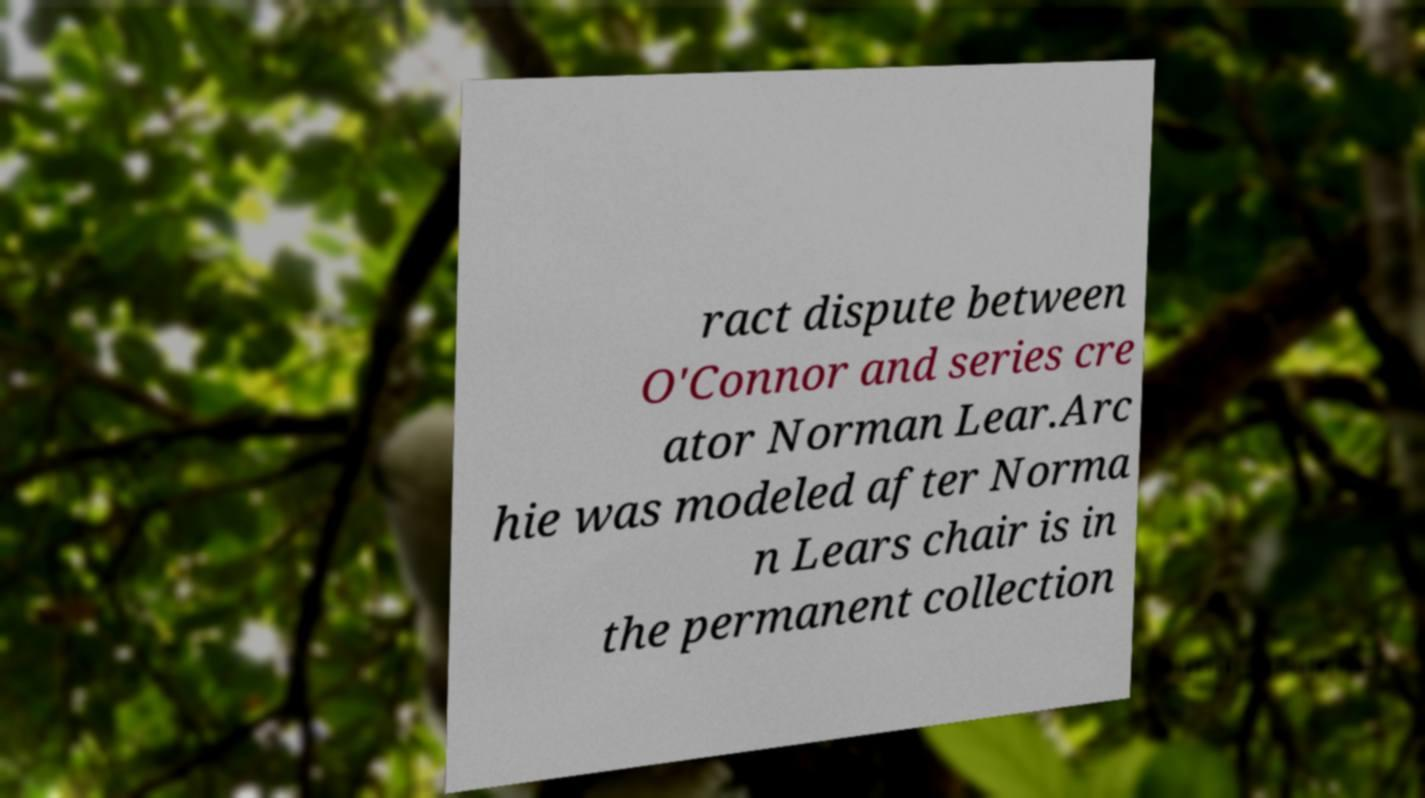Could you assist in decoding the text presented in this image and type it out clearly? ract dispute between O'Connor and series cre ator Norman Lear.Arc hie was modeled after Norma n Lears chair is in the permanent collection 